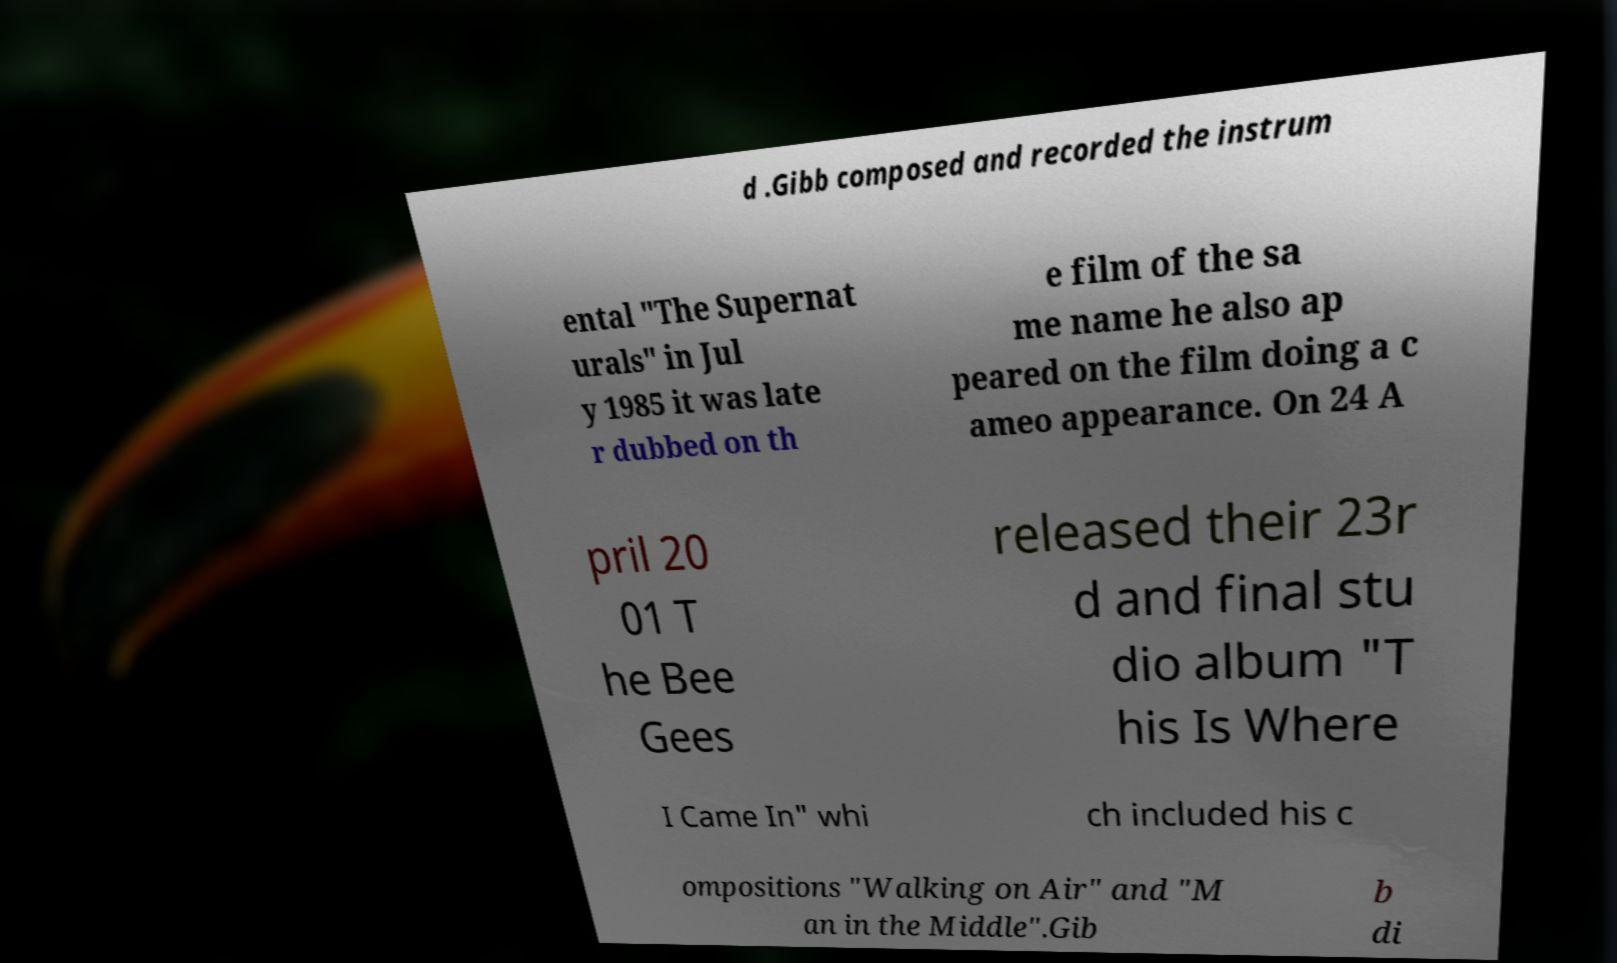Please identify and transcribe the text found in this image. d .Gibb composed and recorded the instrum ental "The Supernat urals" in Jul y 1985 it was late r dubbed on th e film of the sa me name he also ap peared on the film doing a c ameo appearance. On 24 A pril 20 01 T he Bee Gees released their 23r d and final stu dio album "T his Is Where I Came In" whi ch included his c ompositions "Walking on Air" and "M an in the Middle".Gib b di 